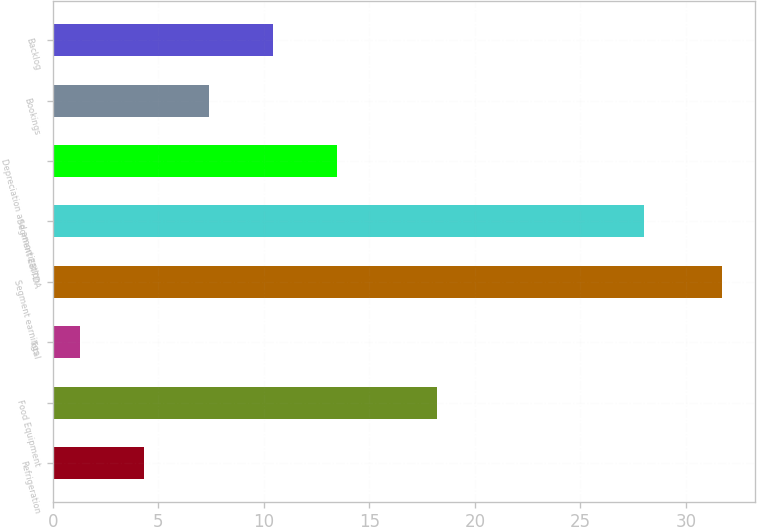<chart> <loc_0><loc_0><loc_500><loc_500><bar_chart><fcel>Refrigeration<fcel>Food Equipment<fcel>Total<fcel>Segment earnings<fcel>Segment EBITDA<fcel>Depreciation and amortization<fcel>Bookings<fcel>Backlog<nl><fcel>4.34<fcel>18.2<fcel>1.3<fcel>31.7<fcel>28<fcel>13.46<fcel>7.38<fcel>10.42<nl></chart> 